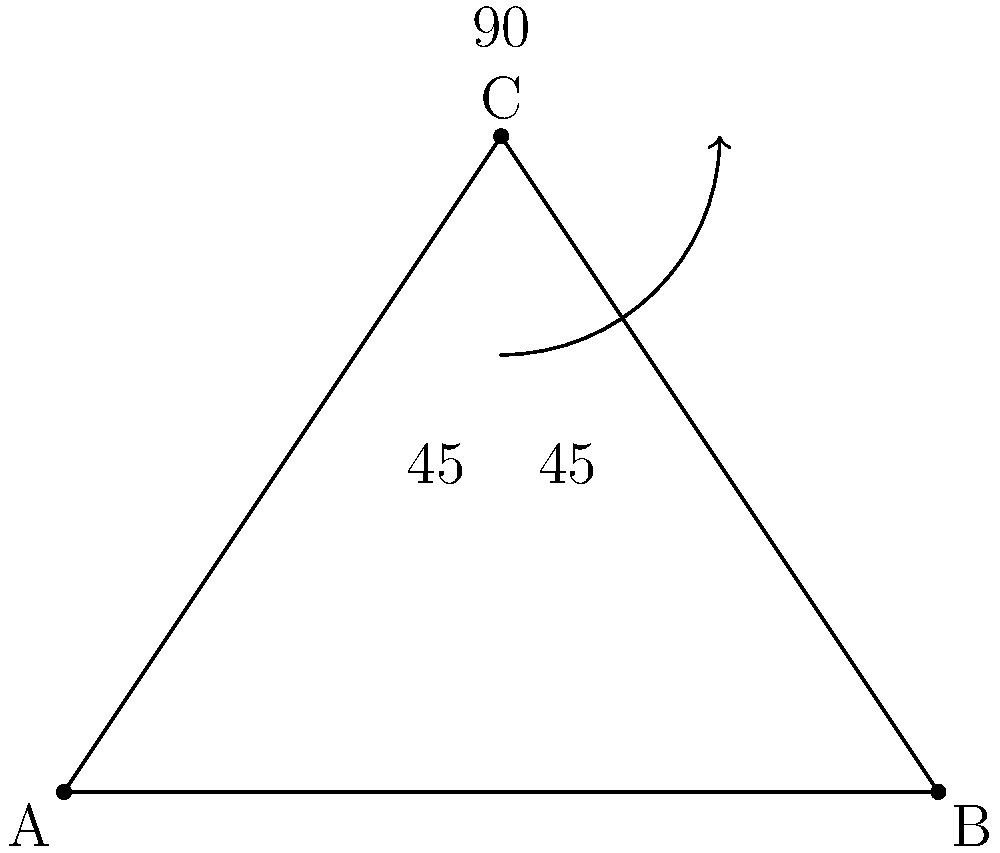In a silent film scene, a mime pretends to be trapped in a box. The angle between the mime's outstretched arms forms an isosceles triangle with the imaginary box's floor. If the angle at the top of this triangle is 90°, what is the angle between each arm and the floor? Let's approach this step-by-step:

1) The mime's arms and the floor form an isosceles triangle. This means the two base angles are equal.

2) We know that the angle at the top of the triangle (where the arms meet) is 90°.

3) In any triangle, the sum of all interior angles is always 180°.

4) Let's call the unknown base angle $x$. Since there are two of these angles (one for each arm), we can set up an equation:

   $x + x + 90° = 180°$

5) Simplify:
   $2x + 90° = 180°$

6) Subtract 90° from both sides:
   $2x = 90°$

7) Divide both sides by 2:
   $x = 45°$

Therefore, the angle between each arm and the floor is 45°.
Answer: 45° 